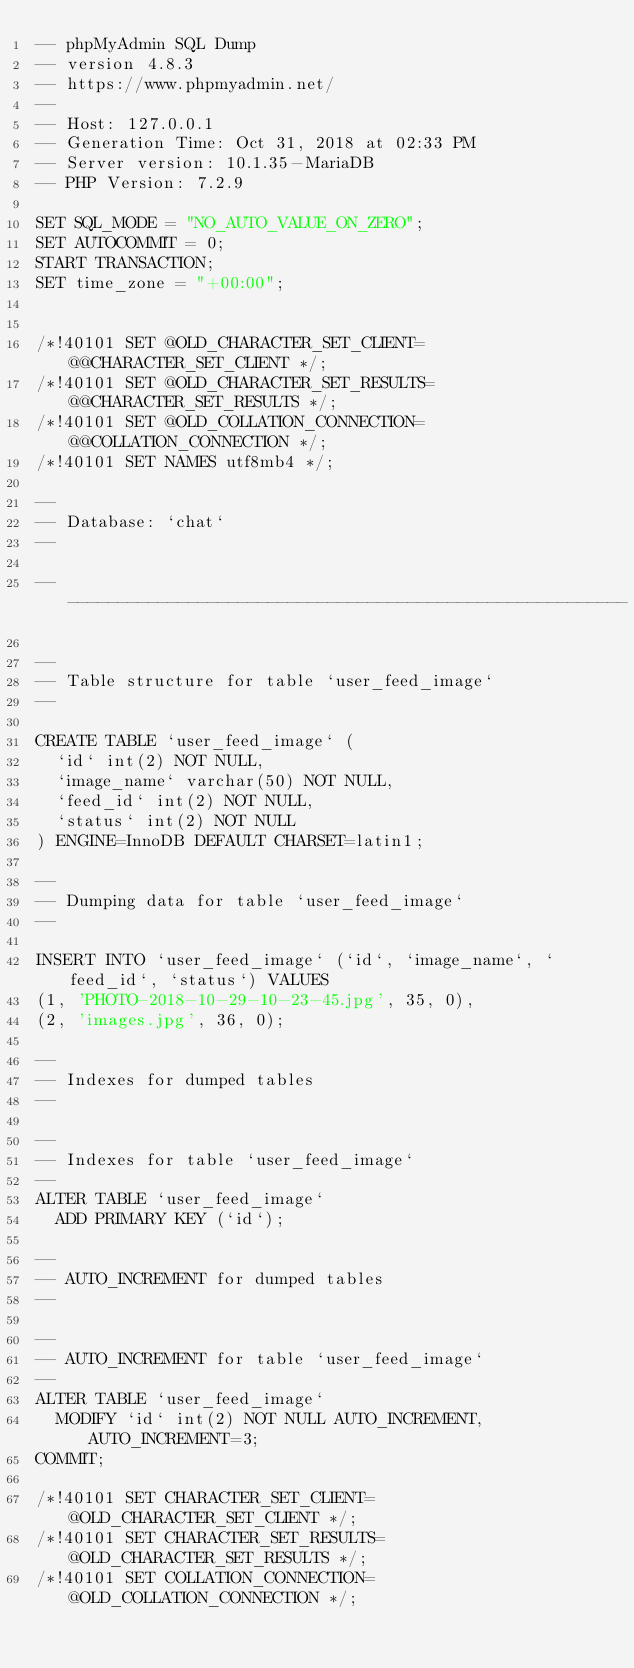Convert code to text. <code><loc_0><loc_0><loc_500><loc_500><_SQL_>-- phpMyAdmin SQL Dump
-- version 4.8.3
-- https://www.phpmyadmin.net/
--
-- Host: 127.0.0.1
-- Generation Time: Oct 31, 2018 at 02:33 PM
-- Server version: 10.1.35-MariaDB
-- PHP Version: 7.2.9

SET SQL_MODE = "NO_AUTO_VALUE_ON_ZERO";
SET AUTOCOMMIT = 0;
START TRANSACTION;
SET time_zone = "+00:00";


/*!40101 SET @OLD_CHARACTER_SET_CLIENT=@@CHARACTER_SET_CLIENT */;
/*!40101 SET @OLD_CHARACTER_SET_RESULTS=@@CHARACTER_SET_RESULTS */;
/*!40101 SET @OLD_COLLATION_CONNECTION=@@COLLATION_CONNECTION */;
/*!40101 SET NAMES utf8mb4 */;

--
-- Database: `chat`
--

-- --------------------------------------------------------

--
-- Table structure for table `user_feed_image`
--

CREATE TABLE `user_feed_image` (
  `id` int(2) NOT NULL,
  `image_name` varchar(50) NOT NULL,
  `feed_id` int(2) NOT NULL,
  `status` int(2) NOT NULL
) ENGINE=InnoDB DEFAULT CHARSET=latin1;

--
-- Dumping data for table `user_feed_image`
--

INSERT INTO `user_feed_image` (`id`, `image_name`, `feed_id`, `status`) VALUES
(1, 'PHOTO-2018-10-29-10-23-45.jpg', 35, 0),
(2, 'images.jpg', 36, 0);

--
-- Indexes for dumped tables
--

--
-- Indexes for table `user_feed_image`
--
ALTER TABLE `user_feed_image`
  ADD PRIMARY KEY (`id`);

--
-- AUTO_INCREMENT for dumped tables
--

--
-- AUTO_INCREMENT for table `user_feed_image`
--
ALTER TABLE `user_feed_image`
  MODIFY `id` int(2) NOT NULL AUTO_INCREMENT, AUTO_INCREMENT=3;
COMMIT;

/*!40101 SET CHARACTER_SET_CLIENT=@OLD_CHARACTER_SET_CLIENT */;
/*!40101 SET CHARACTER_SET_RESULTS=@OLD_CHARACTER_SET_RESULTS */;
/*!40101 SET COLLATION_CONNECTION=@OLD_COLLATION_CONNECTION */;
</code> 